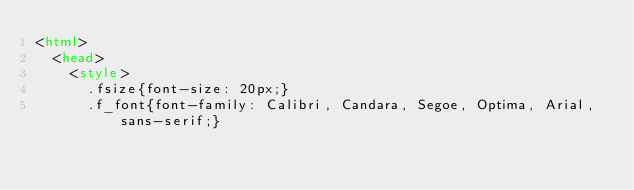Convert code to text. <code><loc_0><loc_0><loc_500><loc_500><_HTML_><html>
	<head>
		<style>
			.fsize{font-size: 20px;}
			.f_font{font-family: Calibri, Candara, Segoe, Optima, Arial, sans-serif;}</code> 